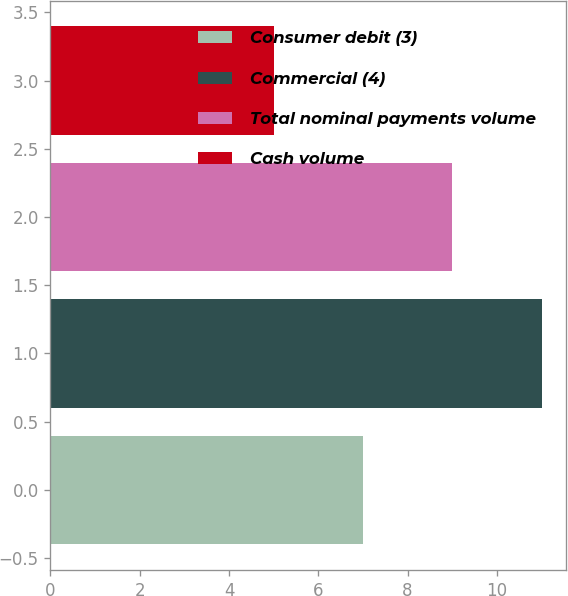Convert chart to OTSL. <chart><loc_0><loc_0><loc_500><loc_500><bar_chart><fcel>Consumer debit (3)<fcel>Commercial (4)<fcel>Total nominal payments volume<fcel>Cash volume<nl><fcel>7<fcel>11<fcel>9<fcel>5<nl></chart> 